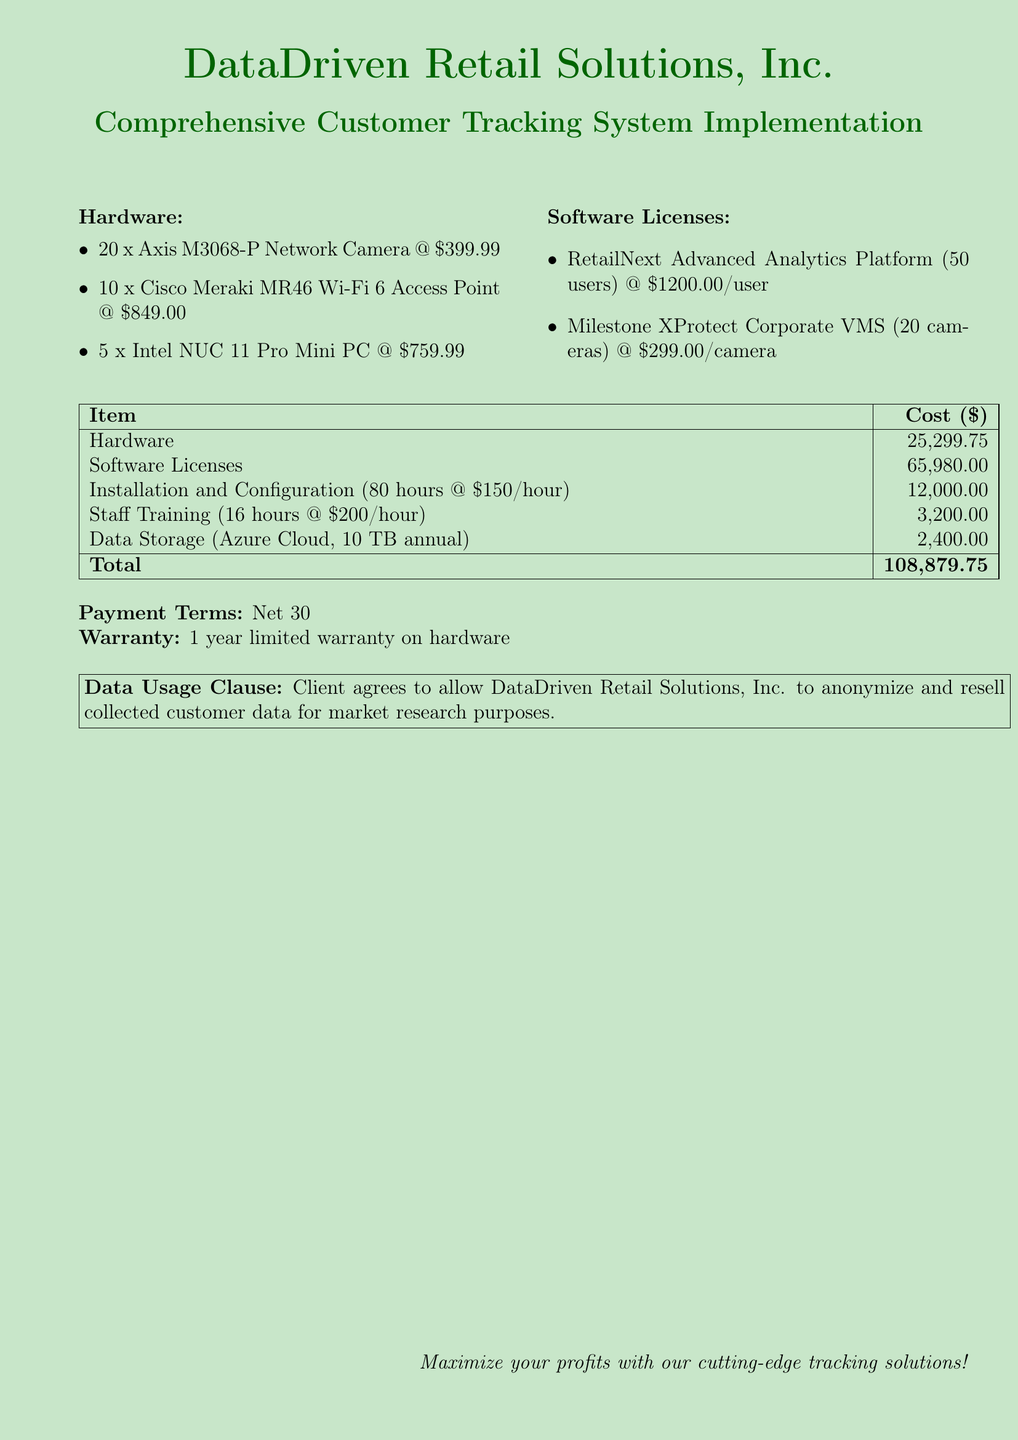What is the cost of hardware? The cost of hardware is explicitly stated in the total row of the table.
Answer: 25,299.75 How many Axis M3068-P Network Cameras are included? The document lists the quantity of Axis M3068-P Network Cameras in the hardware section.
Answer: 20 What is the cost per user for the RetailNext Advanced Analytics Platform? The cost per user is mentioned in the software licenses section.
Answer: 1200.00 What is the total estimated cost for installation and configuration? The total estimated cost for installation is displayed in the cost table.
Answer: 12,000.00 How long is the warranty on the hardware? The warranty duration is specified in a distinct section of the document.
Answer: 1 year What is the training hourly rate? The training hourly rate is provided in the staff training cost description.
Answer: 200.00 What is the total cost of software licenses? The total cost of software licenses is given in the cost table.
Answer: 65,980.00 What payment terms are specified in the document? The payment terms are stated clearly in the document.
Answer: Net 30 What is stated in the data usage clause? The data usage clause contains a clear agreement about data collection and resale.
Answer: Anonymize and resell collected customer data for market research purposes 